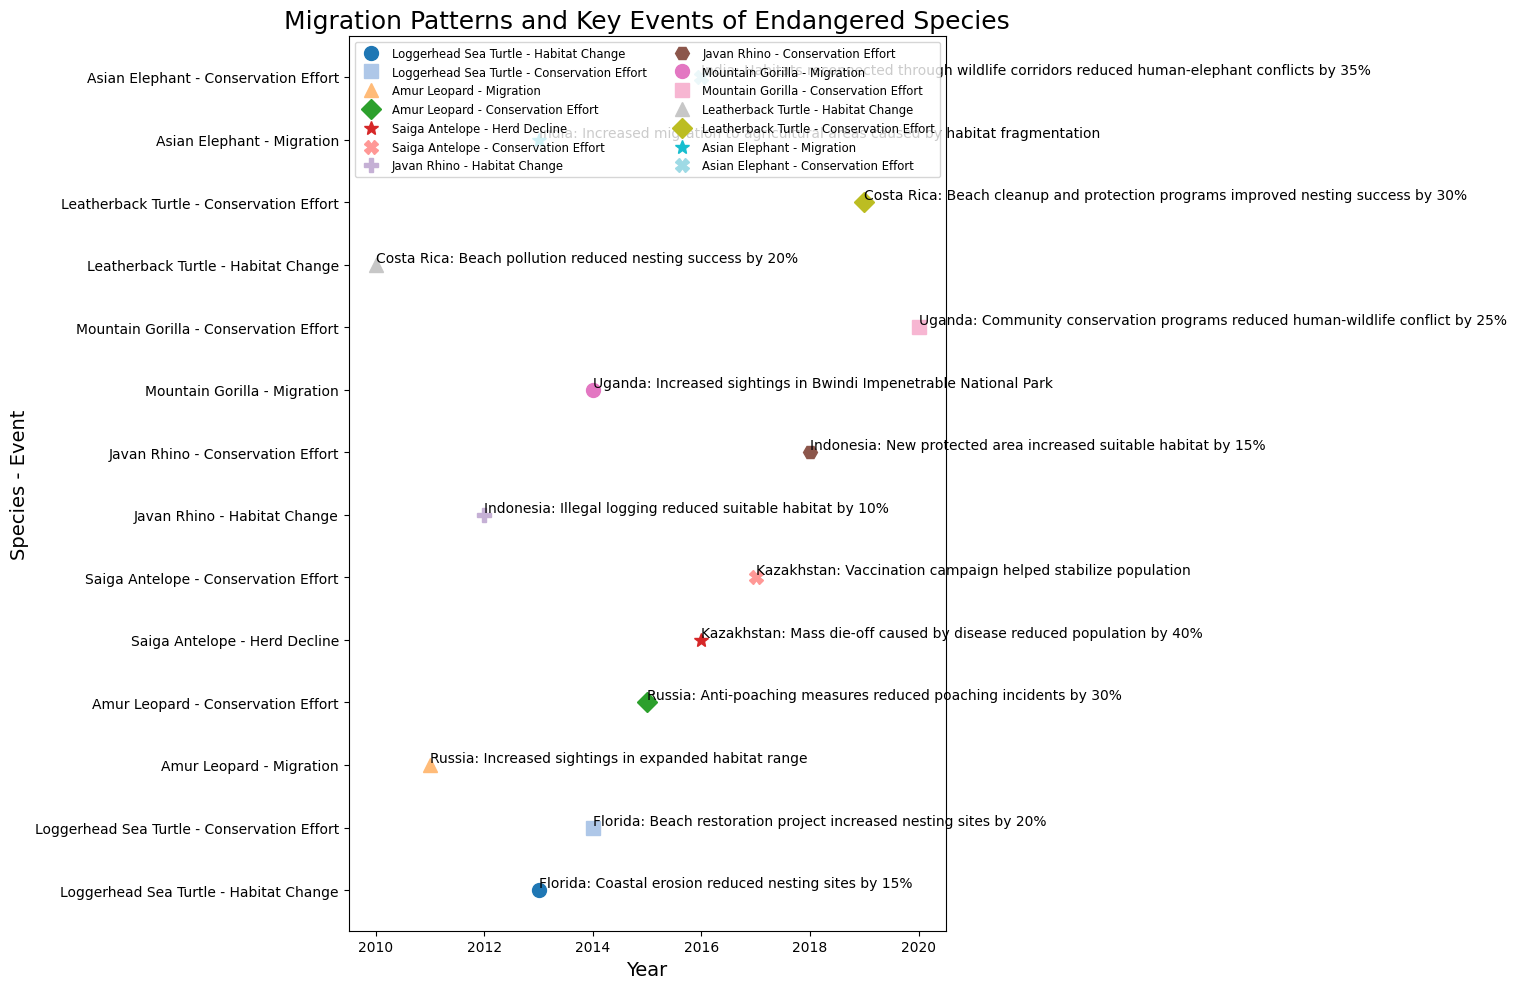What species experienced a habitat improvement after a habitat decline? To find the species with both habitat decline and improvement, look for those with events labeled "Habitat Change" and "Conservation Effort". Javan Rhino had a habitat reduction in 2012 and improvement in 2018.
Answer: Javan Rhino Which conservation effort reduced human-wildlife conflict and by what percentage? Look for "Conservation Effort" events specifically mentioning "human-wildlife conflict". The Mountain Gorilla in Uganda saw a 25% reduction in 2020.
Answer: Mountain Gorilla, 25% Which species had the most significant population reduction due to disease and what percentage was reduced? Identify events labeled "Herd Decline" and check details for disease-related population reductions. Saiga Antelope experienced a 40% reduction in 2016.
Answer: Saiga Antelope, 40% How many species had conservation efforts that resulted in habitat improvement? Count the species with "Conservation Effort" events specifically mentioning "habitat" improvements. Conserved habitats improved for Loggerhead Sea Turtle, Javan Rhino, and Leatherback Turtle.
Answer: 3 species Which species' conservation effort resulted in the highest increase in suitable habitat, and what was the percentage increase? Identify the "Conservation Effort" events mentioning habitat increase and compare the percentages. The Loggerhead Sea Turtle had a 20% increase in Florida in 2014.
Answer: Loggerhead Sea Turtle, 20% Which location had conservation efforts involving wildlife corridors? Look for "Conservation Effort" events and find the details mentioning "wildlife corridors". India had such efforts for the Asian Elephant in 2016.
Answer: India How did the nesting success of Leatherback Turtles change from 2010 to 2019 due to conservation efforts? Compare the habitat change in 2010 with the conservation effort in 2019 for the Leatherback Turtle. Nesting success went from a 20% reduction in 2010 to a 30% improvement in 2019.
Answer: Improved by 50% Which species had increased sightings in expanded habitat ranges? Check the "Migration" events for mentions of expanded habitat ranges. The Amur Leopard in Russia in 2011 and the Mountain Gorilla in Uganda in 2014 both fit this description.
Answer: Amur Leopard and Mountain Gorilla Which conservation effort resulted in the largest percentage impact on protecting the species from a human threat? Look for "Conservation Effort" events with percentage impacts reducing human threats. Amur Leopard's anti-poaching measures reduced incidents by 30% in 2015.
Answer: Amur Leopard, 30% 